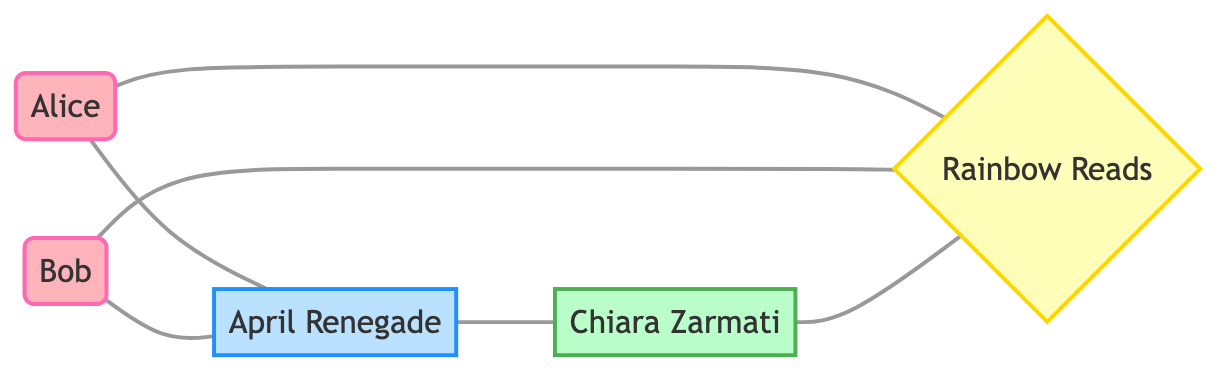What are the names of the book club members? The diagram contains two book club members: Alice and Bob. Their names are represented in the nodes labeled as "Book Club Member".
Answer: Alice, Bob Who has read "April Renegade"? The diagram shows two connections from book club members (Alice and Bob) to the book titled "April Renegade", indicating that both have read it.
Answer: Alice, Bob How many nodes are there in total? The diagram includes 5 distinct nodes: 2 book club members, 1 author, 1 book, and 1 book club. Counting these provides the total number of nodes.
Answer: 5 What is the genre of "April Renegade"? The book node for "April Renegade" includes an attribute specifying its genre as "LGBTQ+ narrative". This genre is tied directly to the book's identity in the diagram.
Answer: LGBTQ+ narrative Which author is featured in the Rainbow Reads book club? The diagram specifies that Chiara Zarmati is connected to the Rainbow Reads book club, indicated by the label "featured author in".
Answer: Chiara Zarmati How many edges are connected to the book "April Renegade"? Examining the edges, "April Renegade" connects with two book club members (Alice and Bob) and one author (Chiara Zarmati), resulting in a total of three edges.
Answer: 3 What relationship do Alice and Bob have to the "Rainbow Reads" club? The diagram indicates that both Alice and Bob are members of "Rainbow Reads", which is explicit in their connections to the club node.
Answer: member of Is there a direct connection between the author Chiara Zarmati and the book "April Renegade"? The diagram explicitly shows an edge labeled "written by" connecting Chiara Zarmati to the book "April Renegade", indicating a direct relationship as the author of the book.
Answer: Yes What is the primary focus of the Rainbow Reads book club? The diagram highlights the focus of "Rainbow Reads" as being on "LGBTQ+ literature", as attributed in the club's node.
Answer: LGBTQ+ literature 